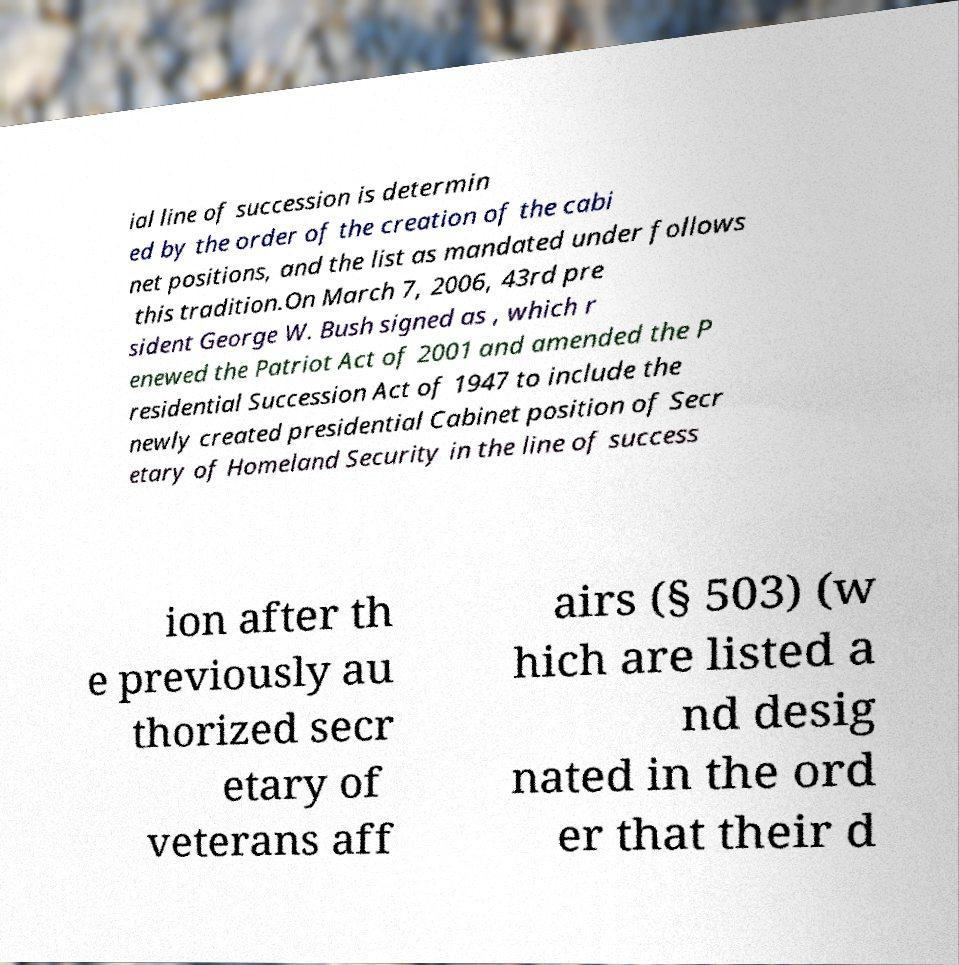Could you extract and type out the text from this image? ial line of succession is determin ed by the order of the creation of the cabi net positions, and the list as mandated under follows this tradition.On March 7, 2006, 43rd pre sident George W. Bush signed as , which r enewed the Patriot Act of 2001 and amended the P residential Succession Act of 1947 to include the newly created presidential Cabinet position of Secr etary of Homeland Security in the line of success ion after th e previously au thorized secr etary of veterans aff airs (§ 503) (w hich are listed a nd desig nated in the ord er that their d 